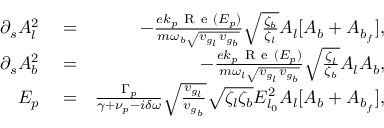<formula> <loc_0><loc_0><loc_500><loc_500>\begin{array} { r l r } { \partial _ { s } A _ { l } ^ { 2 } } & = } & { - \frac { e k _ { p } R e ( E _ { p } ) } { m \omega _ { b } \sqrt { v _ { g _ { l } } v _ { g _ { b } } } } \sqrt { \frac { \zeta _ { b } } { \zeta _ { l } } } A _ { l } [ A _ { b } + A _ { b _ { f } } ] , } \\ { \partial _ { s } A _ { b } ^ { 2 } } & = } & { - \frac { e k _ { p } R e ( E _ { p } ) } { m \omega _ { l } \sqrt { v _ { g _ { l } } v _ { g _ { b } } } } \sqrt { \frac { \zeta _ { l } } { \zeta _ { b } } } A _ { l } A _ { b } , } \\ { E _ { p } } & = } & { \frac { \Gamma _ { p } } { \gamma + \nu _ { p } - i \delta \omega } \sqrt { \frac { v _ { g _ { l } } } { v _ { g _ { b } } } } \sqrt { \zeta _ { l } \zeta _ { b } } E _ { l _ { 0 } } ^ { 2 } A _ { l } [ A _ { b } + A _ { b _ { f } } ] , } \end{array}</formula> 